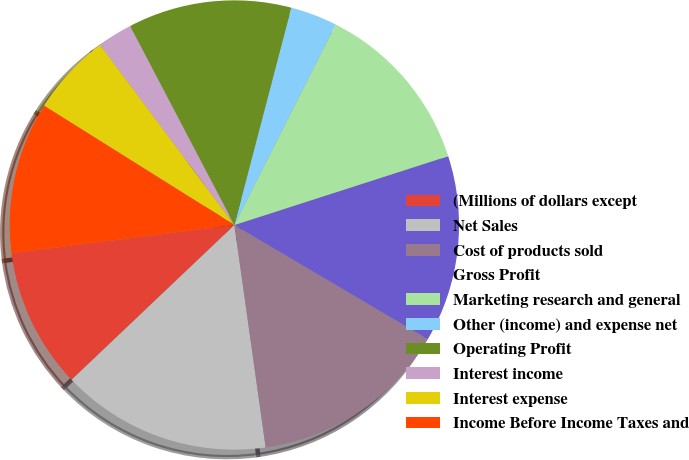Convert chart to OTSL. <chart><loc_0><loc_0><loc_500><loc_500><pie_chart><fcel>(Millions of dollars except<fcel>Net Sales<fcel>Cost of products sold<fcel>Gross Profit<fcel>Marketing research and general<fcel>Other (income) and expense net<fcel>Operating Profit<fcel>Interest income<fcel>Interest expense<fcel>Income Before Income Taxes and<nl><fcel>10.08%<fcel>15.13%<fcel>14.29%<fcel>13.44%<fcel>12.6%<fcel>3.36%<fcel>11.76%<fcel>2.52%<fcel>5.88%<fcel>10.92%<nl></chart> 